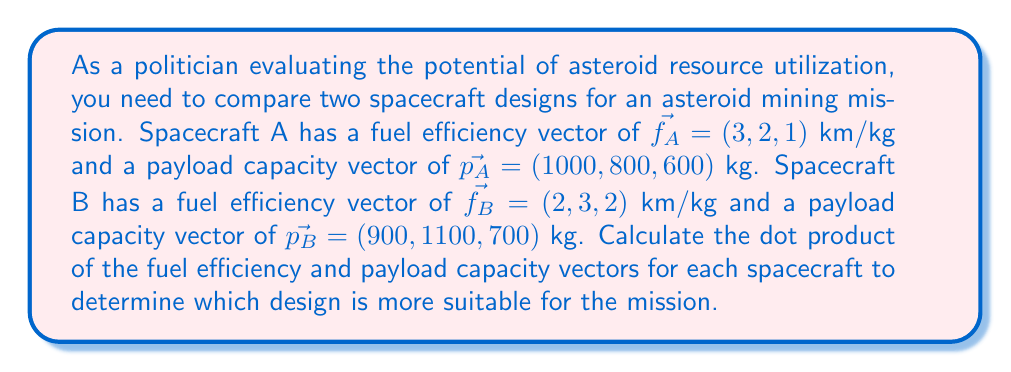Solve this math problem. To determine which spacecraft design is more suitable, we'll calculate the dot product of the fuel efficiency and payload capacity vectors for each spacecraft. The higher dot product indicates a better overall performance.

For Spacecraft A:
1. Fuel efficiency vector: $\vec{f_A} = (3, 2, 1)$ km/kg
2. Payload capacity vector: $\vec{p_A} = (1000, 800, 600)$ kg
3. Calculate the dot product:
   $$\vec{f_A} \cdot \vec{p_A} = (3 \times 1000) + (2 \times 800) + (1 \times 600)$$
   $$\vec{f_A} \cdot \vec{p_A} = 3000 + 1600 + 600 = 5200$$ km·kg/kg

For Spacecraft B:
1. Fuel efficiency vector: $\vec{f_B} = (2, 3, 2)$ km/kg
2. Payload capacity vector: $\vec{p_B} = (900, 1100, 700)$ kg
3. Calculate the dot product:
   $$\vec{f_B} \cdot \vec{p_B} = (2 \times 900) + (3 \times 1100) + (2 \times 700)$$
   $$\vec{f_B} \cdot \vec{p_B} = 1800 + 3300 + 1400 = 6500$$ km·kg/kg

Comparing the results:
Spacecraft A: 5200 km·kg/kg
Spacecraft B: 6500 km·kg/kg

Spacecraft B has a higher dot product, indicating better overall performance in terms of fuel efficiency and payload capacity.
Answer: Spacecraft B (6500 km·kg/kg) 